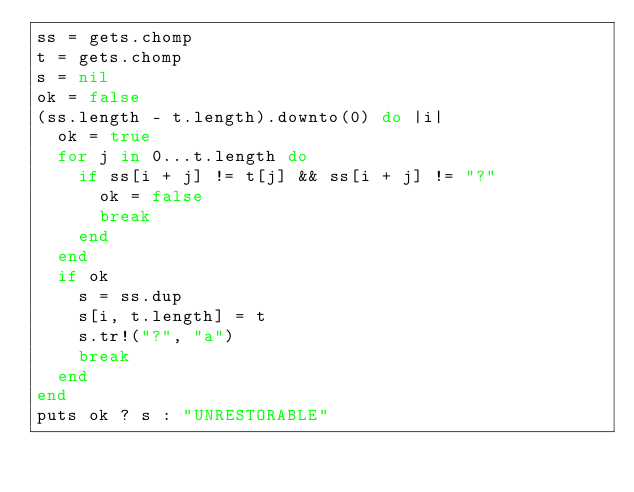<code> <loc_0><loc_0><loc_500><loc_500><_Ruby_>ss = gets.chomp
t = gets.chomp
s = nil
ok = false
(ss.length - t.length).downto(0) do |i|
  ok = true
  for j in 0...t.length do
    if ss[i + j] != t[j] && ss[i + j] != "?"
      ok = false
      break
    end
  end
  if ok
    s = ss.dup
    s[i, t.length] = t
    s.tr!("?", "a")
    break
  end
end
puts ok ? s : "UNRESTORABLE"
</code> 